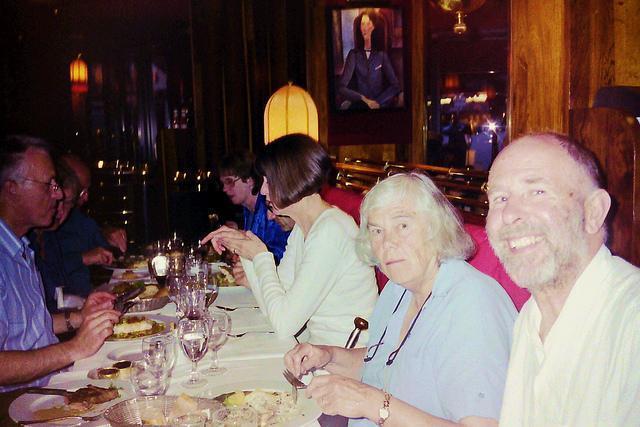How many people can be seen?
Give a very brief answer. 7. 